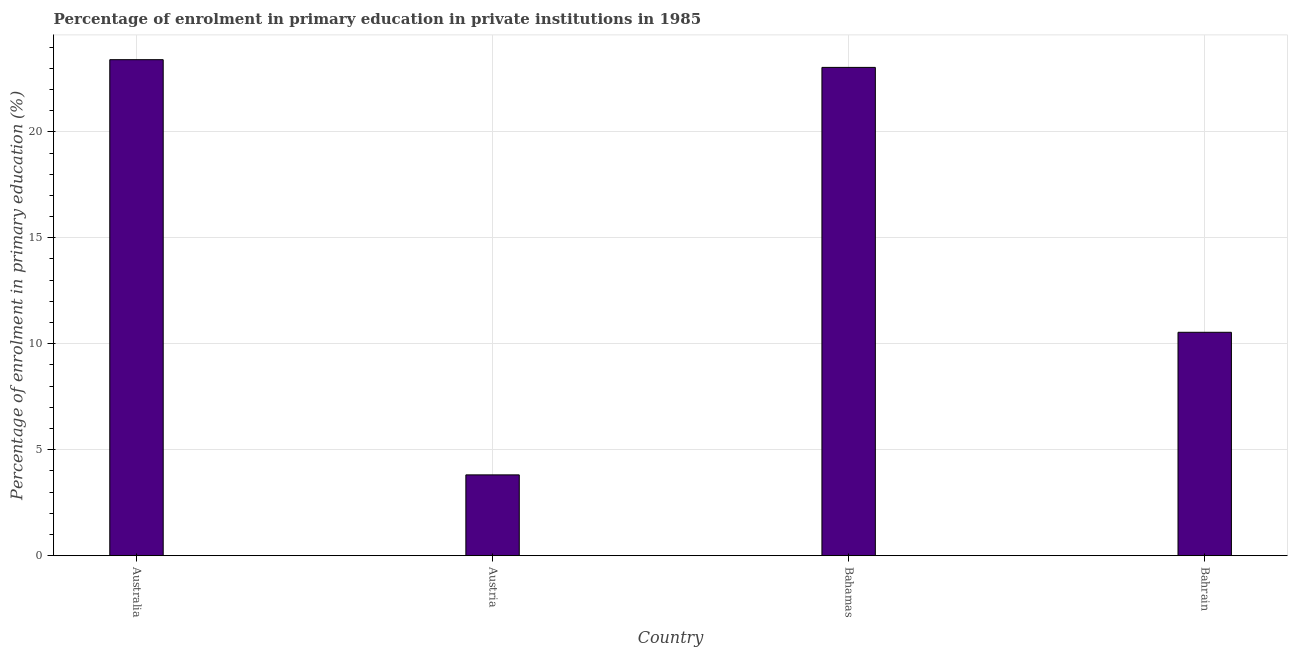Does the graph contain any zero values?
Give a very brief answer. No. What is the title of the graph?
Make the answer very short. Percentage of enrolment in primary education in private institutions in 1985. What is the label or title of the X-axis?
Offer a very short reply. Country. What is the label or title of the Y-axis?
Make the answer very short. Percentage of enrolment in primary education (%). What is the enrolment percentage in primary education in Australia?
Your response must be concise. 23.4. Across all countries, what is the maximum enrolment percentage in primary education?
Provide a succinct answer. 23.4. Across all countries, what is the minimum enrolment percentage in primary education?
Keep it short and to the point. 3.81. What is the sum of the enrolment percentage in primary education?
Ensure brevity in your answer.  60.8. What is the difference between the enrolment percentage in primary education in Australia and Bahrain?
Provide a succinct answer. 12.86. What is the average enrolment percentage in primary education per country?
Offer a terse response. 15.2. What is the median enrolment percentage in primary education?
Give a very brief answer. 16.79. What is the ratio of the enrolment percentage in primary education in Australia to that in Bahamas?
Give a very brief answer. 1.02. Is the enrolment percentage in primary education in Bahamas less than that in Bahrain?
Keep it short and to the point. No. What is the difference between the highest and the second highest enrolment percentage in primary education?
Offer a terse response. 0.36. Is the sum of the enrolment percentage in primary education in Bahamas and Bahrain greater than the maximum enrolment percentage in primary education across all countries?
Ensure brevity in your answer.  Yes. What is the difference between the highest and the lowest enrolment percentage in primary education?
Keep it short and to the point. 19.59. In how many countries, is the enrolment percentage in primary education greater than the average enrolment percentage in primary education taken over all countries?
Give a very brief answer. 2. Are the values on the major ticks of Y-axis written in scientific E-notation?
Ensure brevity in your answer.  No. What is the Percentage of enrolment in primary education (%) of Australia?
Keep it short and to the point. 23.4. What is the Percentage of enrolment in primary education (%) of Austria?
Make the answer very short. 3.81. What is the Percentage of enrolment in primary education (%) of Bahamas?
Make the answer very short. 23.04. What is the Percentage of enrolment in primary education (%) of Bahrain?
Offer a terse response. 10.54. What is the difference between the Percentage of enrolment in primary education (%) in Australia and Austria?
Keep it short and to the point. 19.59. What is the difference between the Percentage of enrolment in primary education (%) in Australia and Bahamas?
Your answer should be very brief. 0.36. What is the difference between the Percentage of enrolment in primary education (%) in Australia and Bahrain?
Your response must be concise. 12.86. What is the difference between the Percentage of enrolment in primary education (%) in Austria and Bahamas?
Offer a very short reply. -19.23. What is the difference between the Percentage of enrolment in primary education (%) in Austria and Bahrain?
Give a very brief answer. -6.73. What is the difference between the Percentage of enrolment in primary education (%) in Bahamas and Bahrain?
Your answer should be compact. 12.5. What is the ratio of the Percentage of enrolment in primary education (%) in Australia to that in Austria?
Offer a terse response. 6.14. What is the ratio of the Percentage of enrolment in primary education (%) in Australia to that in Bahrain?
Give a very brief answer. 2.22. What is the ratio of the Percentage of enrolment in primary education (%) in Austria to that in Bahamas?
Your answer should be compact. 0.17. What is the ratio of the Percentage of enrolment in primary education (%) in Austria to that in Bahrain?
Provide a short and direct response. 0.36. What is the ratio of the Percentage of enrolment in primary education (%) in Bahamas to that in Bahrain?
Ensure brevity in your answer.  2.19. 